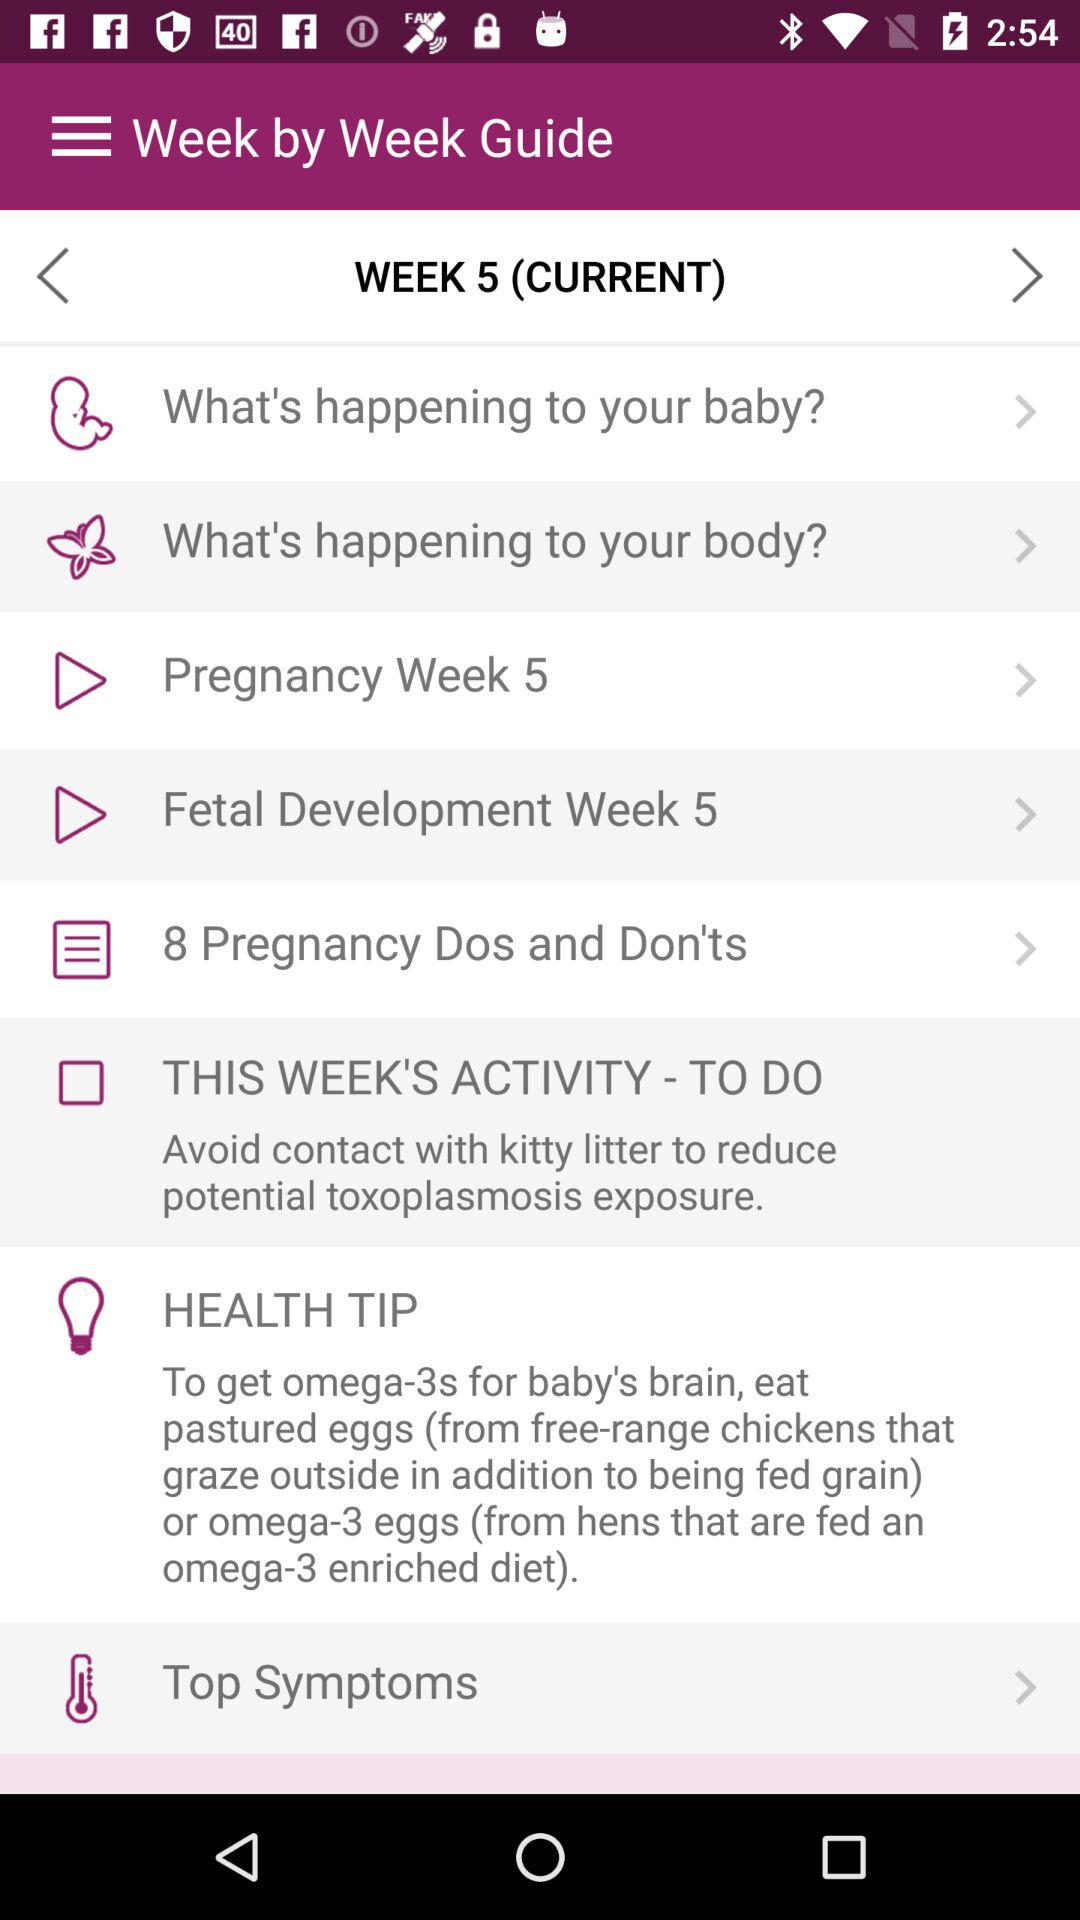What's the number of "Pregnancy Dos and Don'ts"? The number is 8. 